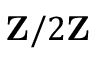<formula> <loc_0><loc_0><loc_500><loc_500>Z / 2 Z</formula> 